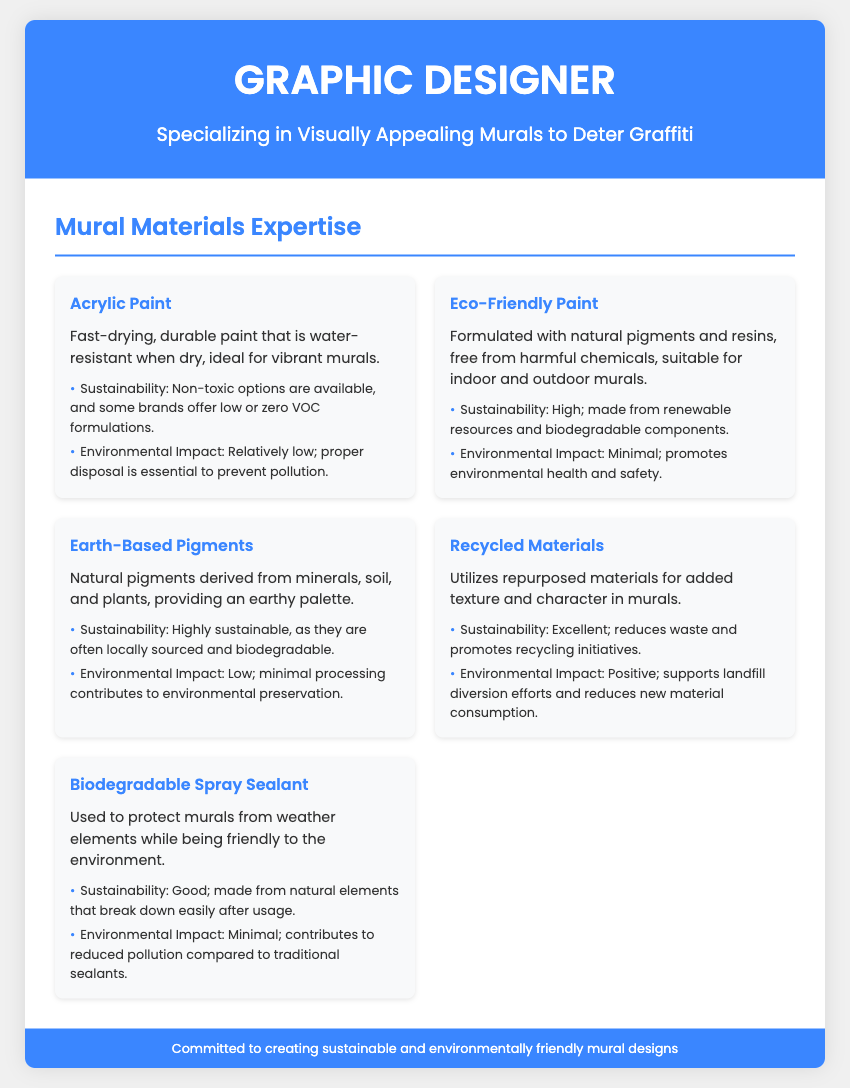What type of paint is mentioned as water-resistant when dry? The document specifically mentions "Acrylic Paint" as being water-resistant when dry, making it suitable for vibrant murals.
Answer: Acrylic Paint Which material is described as being made from renewable resources? The document states that "Eco-Friendly Paint" is formulated with natural pigments and resins made from renewable resources.
Answer: Eco-Friendly Paint How many mural materials are listed in the document? The document contains a section detailing five different mural materials used for creating murals, based on the materials grid provided.
Answer: Five What is the sustainability rating of Earth-Based Pigments? The sustainability of Earth-Based Pigments is described as "Highly sustainable" due to their local sourcing and biodegradability.
Answer: Highly sustainable Which material supports landfill diversion efforts? The material identified as promoting landfill diversion is "Recycled Materials," which utilizes repurposed materials for murals.
Answer: Recycled Materials What is the environmental impact of Biodegradable Spray Sealant? The environmental impact of Biodegradable Spray Sealant is characterized as "Minimal," indicating reduced pollution compared to traditional sealants.
Answer: Minimal What visual style does the resume encompass? The resume is designed with a colorful and modern aesthetic, featuring clean layouts and engaging visuals suitable for a graphic designer specializing in murals.
Answer: Colorful and modern What type of materials did not have harmful chemicals in their ingredients? "Eco-Friendly Paint" is specified as being free from harmful chemicals, making it a safer option.
Answer: Eco-Friendly Paint Which material provides an earthy palette for murals? "Earth-Based Pigments" are highlighted as providing an earthy palette due to their natural origins from minerals, soil, and plants.
Answer: Earth-Based Pigments 